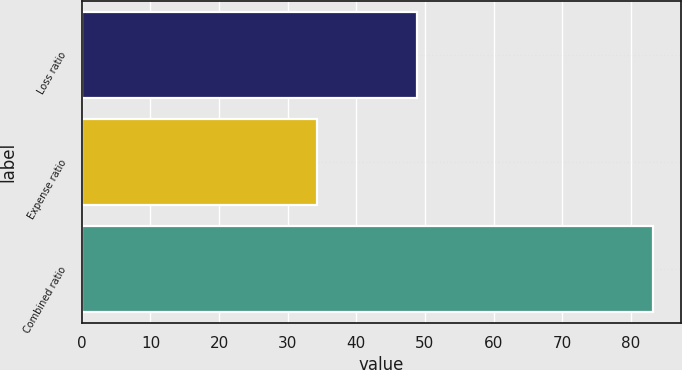Convert chart. <chart><loc_0><loc_0><loc_500><loc_500><bar_chart><fcel>Loss ratio<fcel>Expense ratio<fcel>Combined ratio<nl><fcel>48.9<fcel>34.3<fcel>83.2<nl></chart> 